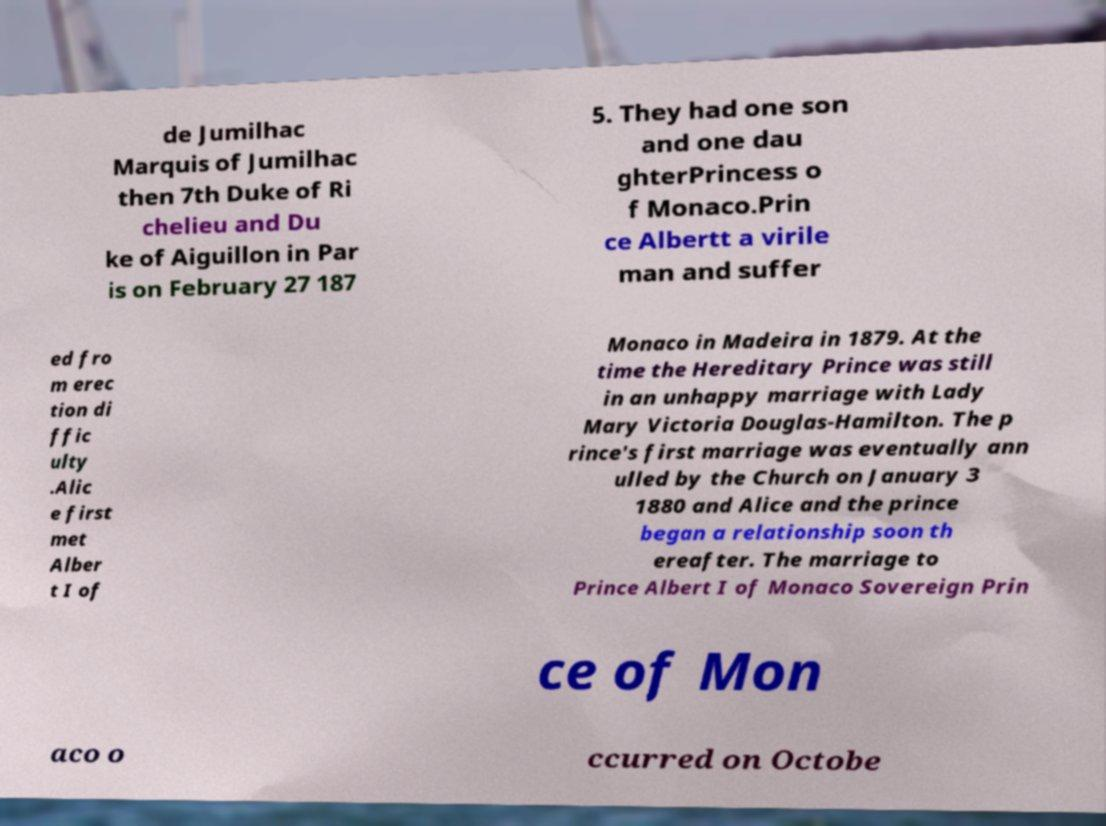Could you extract and type out the text from this image? de Jumilhac Marquis of Jumilhac then 7th Duke of Ri chelieu and Du ke of Aiguillon in Par is on February 27 187 5. They had one son and one dau ghterPrincess o f Monaco.Prin ce Albertt a virile man and suffer ed fro m erec tion di ffic ulty .Alic e first met Alber t I of Monaco in Madeira in 1879. At the time the Hereditary Prince was still in an unhappy marriage with Lady Mary Victoria Douglas-Hamilton. The p rince's first marriage was eventually ann ulled by the Church on January 3 1880 and Alice and the prince began a relationship soon th ereafter. The marriage to Prince Albert I of Monaco Sovereign Prin ce of Mon aco o ccurred on Octobe 